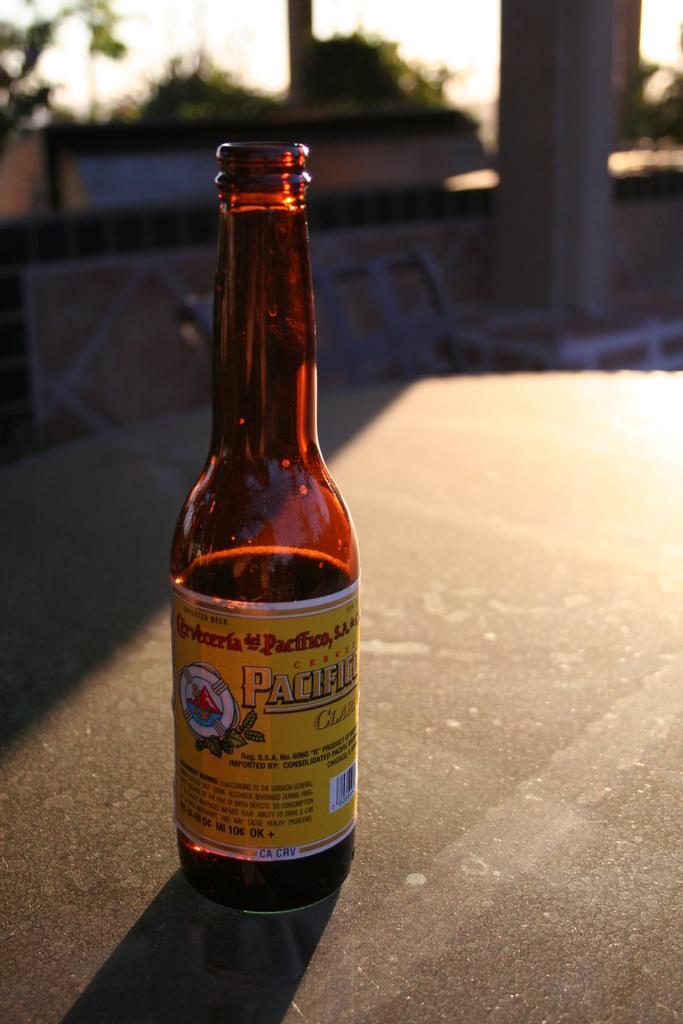<image>
Give a short and clear explanation of the subsequent image. A bottle of Pacific beer sits on a table in sunbeams 